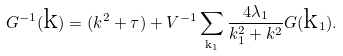Convert formula to latex. <formula><loc_0><loc_0><loc_500><loc_500>G ^ { - 1 } ( { \text  k})=( k^{2}+\tau)+V^{-1}\sum_{{\text   k} _ { 1 } } \frac { 4 \lambda _ { 1 } } { k _ { 1 } ^ { 2 } + k ^ { 2 } } G ( { \text  k}_{1}).</formula> 